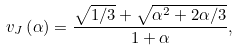Convert formula to latex. <formula><loc_0><loc_0><loc_500><loc_500>v _ { J } \left ( \alpha \right ) = \frac { \sqrt { 1 / 3 } + \sqrt { \alpha ^ { 2 } + 2 \alpha / 3 } } { 1 + \alpha } ,</formula> 